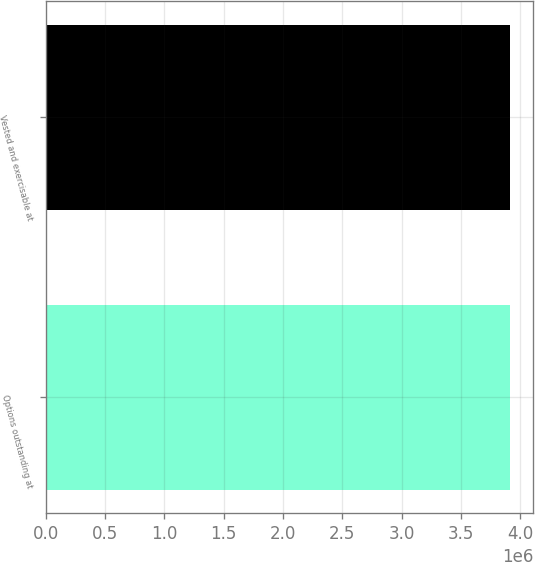<chart> <loc_0><loc_0><loc_500><loc_500><bar_chart><fcel>Options outstanding at<fcel>Vested and exercisable at<nl><fcel>3.9124e+06<fcel>3.9124e+06<nl></chart> 